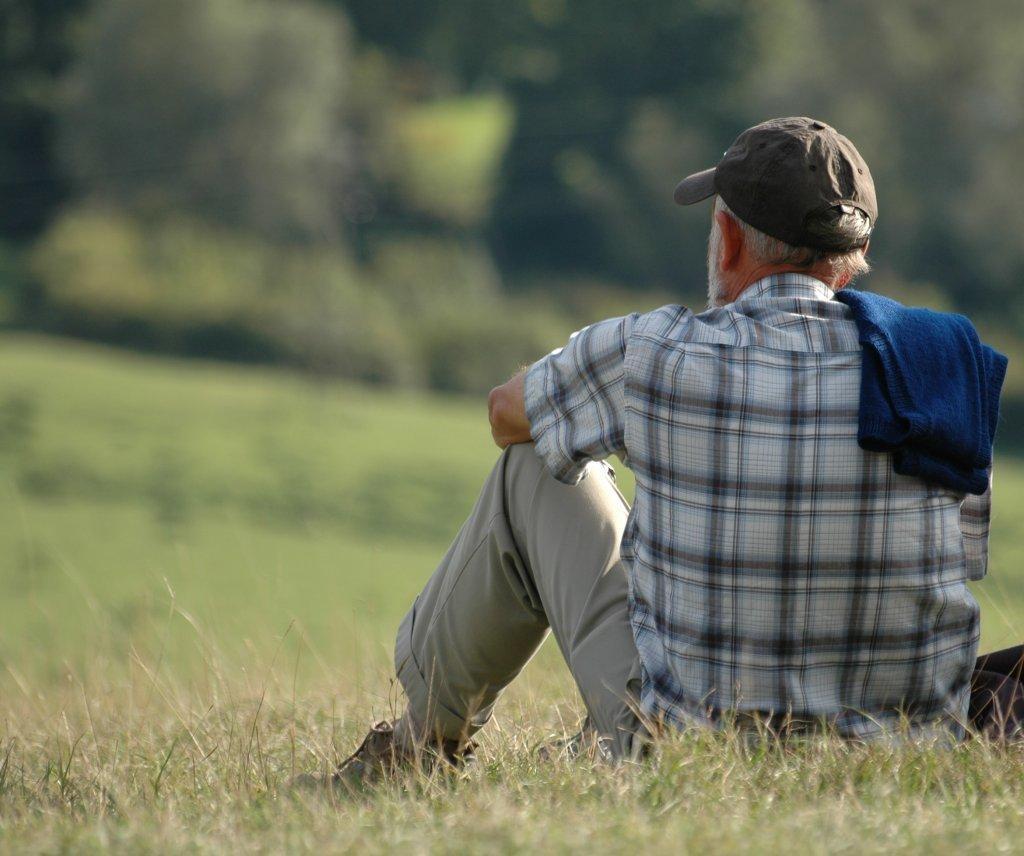In one or two sentences, can you explain what this image depicts? There is one person sitting on a grassy land as we can see on the right side of this image. It seems like there are some trees in the background. 